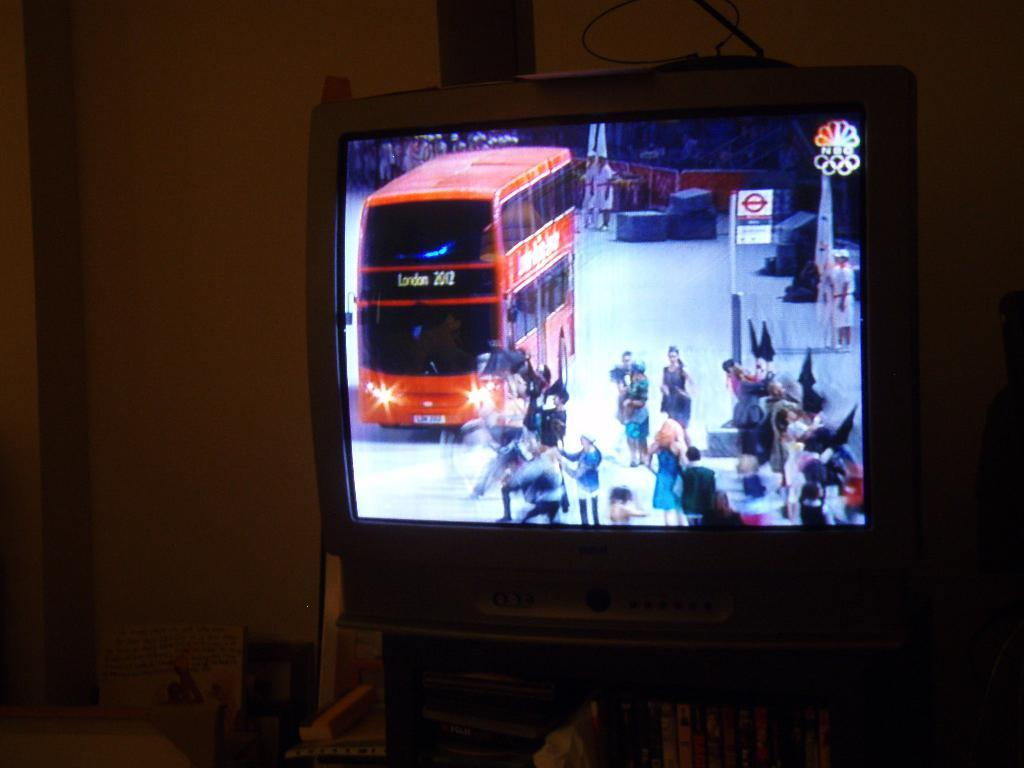<image>
Give a short and clear explanation of the subsequent image. The television channel on is NBC and is covering the London Olympics 